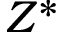<formula> <loc_0><loc_0><loc_500><loc_500>Z ^ { * }</formula> 